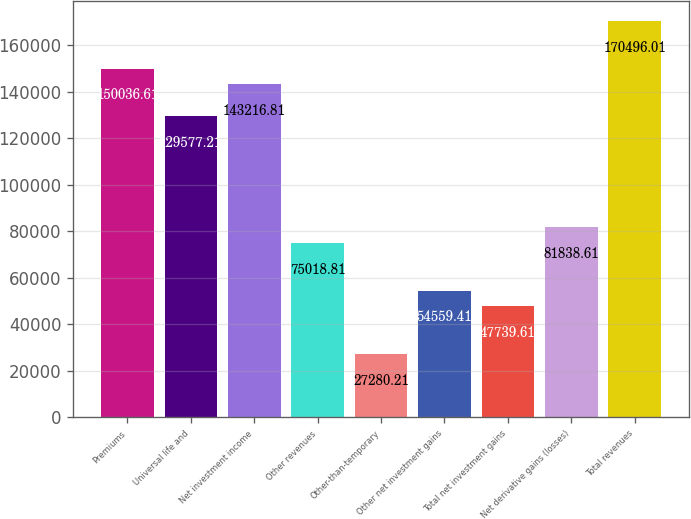<chart> <loc_0><loc_0><loc_500><loc_500><bar_chart><fcel>Premiums<fcel>Universal life and<fcel>Net investment income<fcel>Other revenues<fcel>Other-than-temporary<fcel>Other net investment gains<fcel>Total net investment gains<fcel>Net derivative gains (losses)<fcel>Total revenues<nl><fcel>150037<fcel>129577<fcel>143217<fcel>75018.8<fcel>27280.2<fcel>54559.4<fcel>47739.6<fcel>81838.6<fcel>170496<nl></chart> 